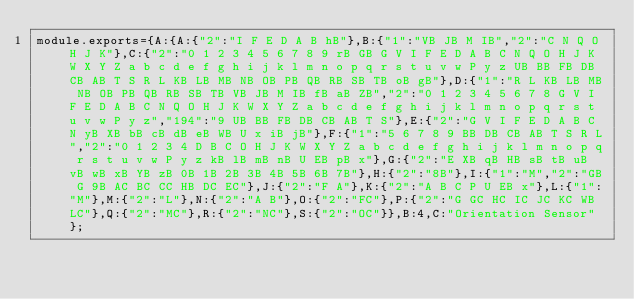<code> <loc_0><loc_0><loc_500><loc_500><_JavaScript_>module.exports={A:{A:{"2":"I F E D A B hB"},B:{"1":"VB JB M IB","2":"C N Q O H J K"},C:{"2":"0 1 2 3 4 5 6 7 8 9 rB GB G V I F E D A B C N Q O H J K W X Y Z a b c d e f g h i j k l m n o p q r s t u v w P y z UB BB FB DB CB AB T S R L KB LB MB NB OB PB QB RB SB TB oB gB"},D:{"1":"R L KB LB MB NB OB PB QB RB SB TB VB JB M IB fB aB ZB","2":"0 1 2 3 4 5 6 7 8 G V I F E D A B C N Q O H J K W X Y Z a b c d e f g h i j k l m n o p q r s t u v w P y z","194":"9 UB BB FB DB CB AB T S"},E:{"2":"G V I F E D A B C N yB XB bB cB dB eB WB U x iB jB"},F:{"1":"5 6 7 8 9 BB DB CB AB T S R L","2":"0 1 2 3 4 D B C O H J K W X Y Z a b c d e f g h i j k l m n o p q r s t u v w P y z kB lB mB nB U EB pB x"},G:{"2":"E XB qB HB sB tB uB vB wB xB YB zB 0B 1B 2B 3B 4B 5B 6B 7B"},H:{"2":"8B"},I:{"1":"M","2":"GB G 9B AC BC CC HB DC EC"},J:{"2":"F A"},K:{"2":"A B C P U EB x"},L:{"1":"M"},M:{"2":"L"},N:{"2":"A B"},O:{"2":"FC"},P:{"2":"G GC HC IC JC KC WB LC"},Q:{"2":"MC"},R:{"2":"NC"},S:{"2":"OC"}},B:4,C:"Orientation Sensor"};
</code> 